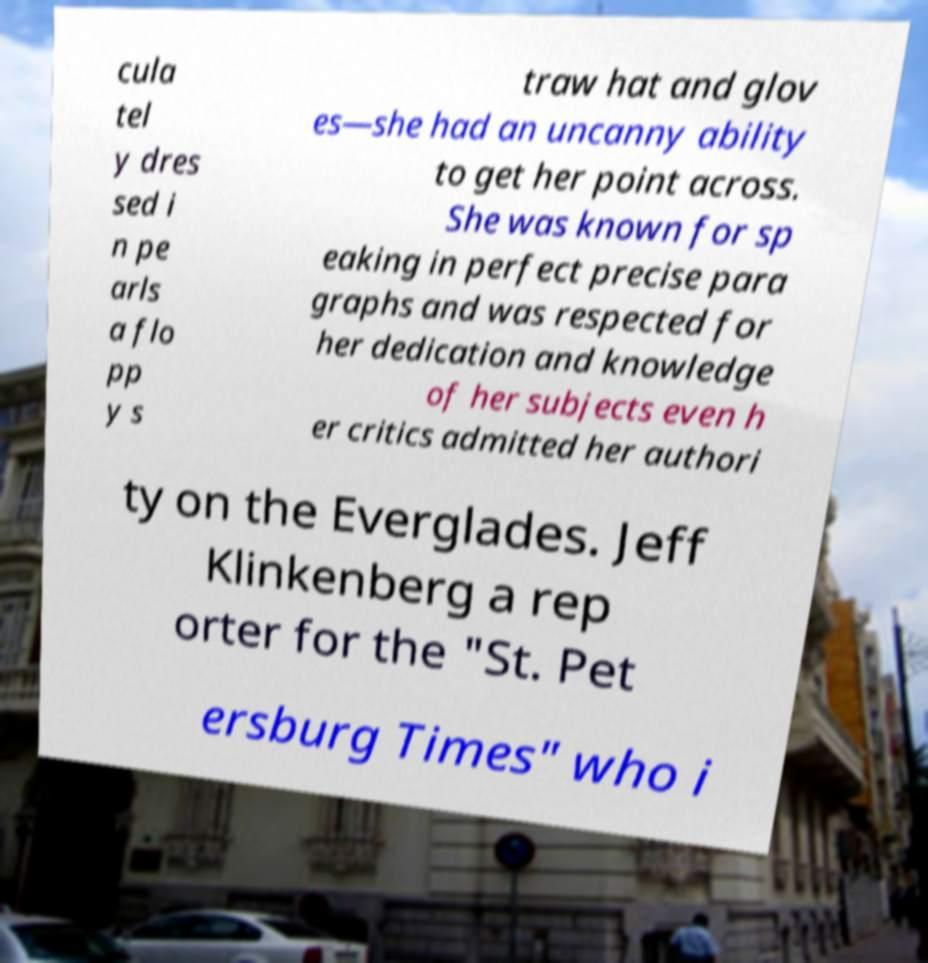There's text embedded in this image that I need extracted. Can you transcribe it verbatim? cula tel y dres sed i n pe arls a flo pp y s traw hat and glov es—she had an uncanny ability to get her point across. She was known for sp eaking in perfect precise para graphs and was respected for her dedication and knowledge of her subjects even h er critics admitted her authori ty on the Everglades. Jeff Klinkenberg a rep orter for the "St. Pet ersburg Times" who i 